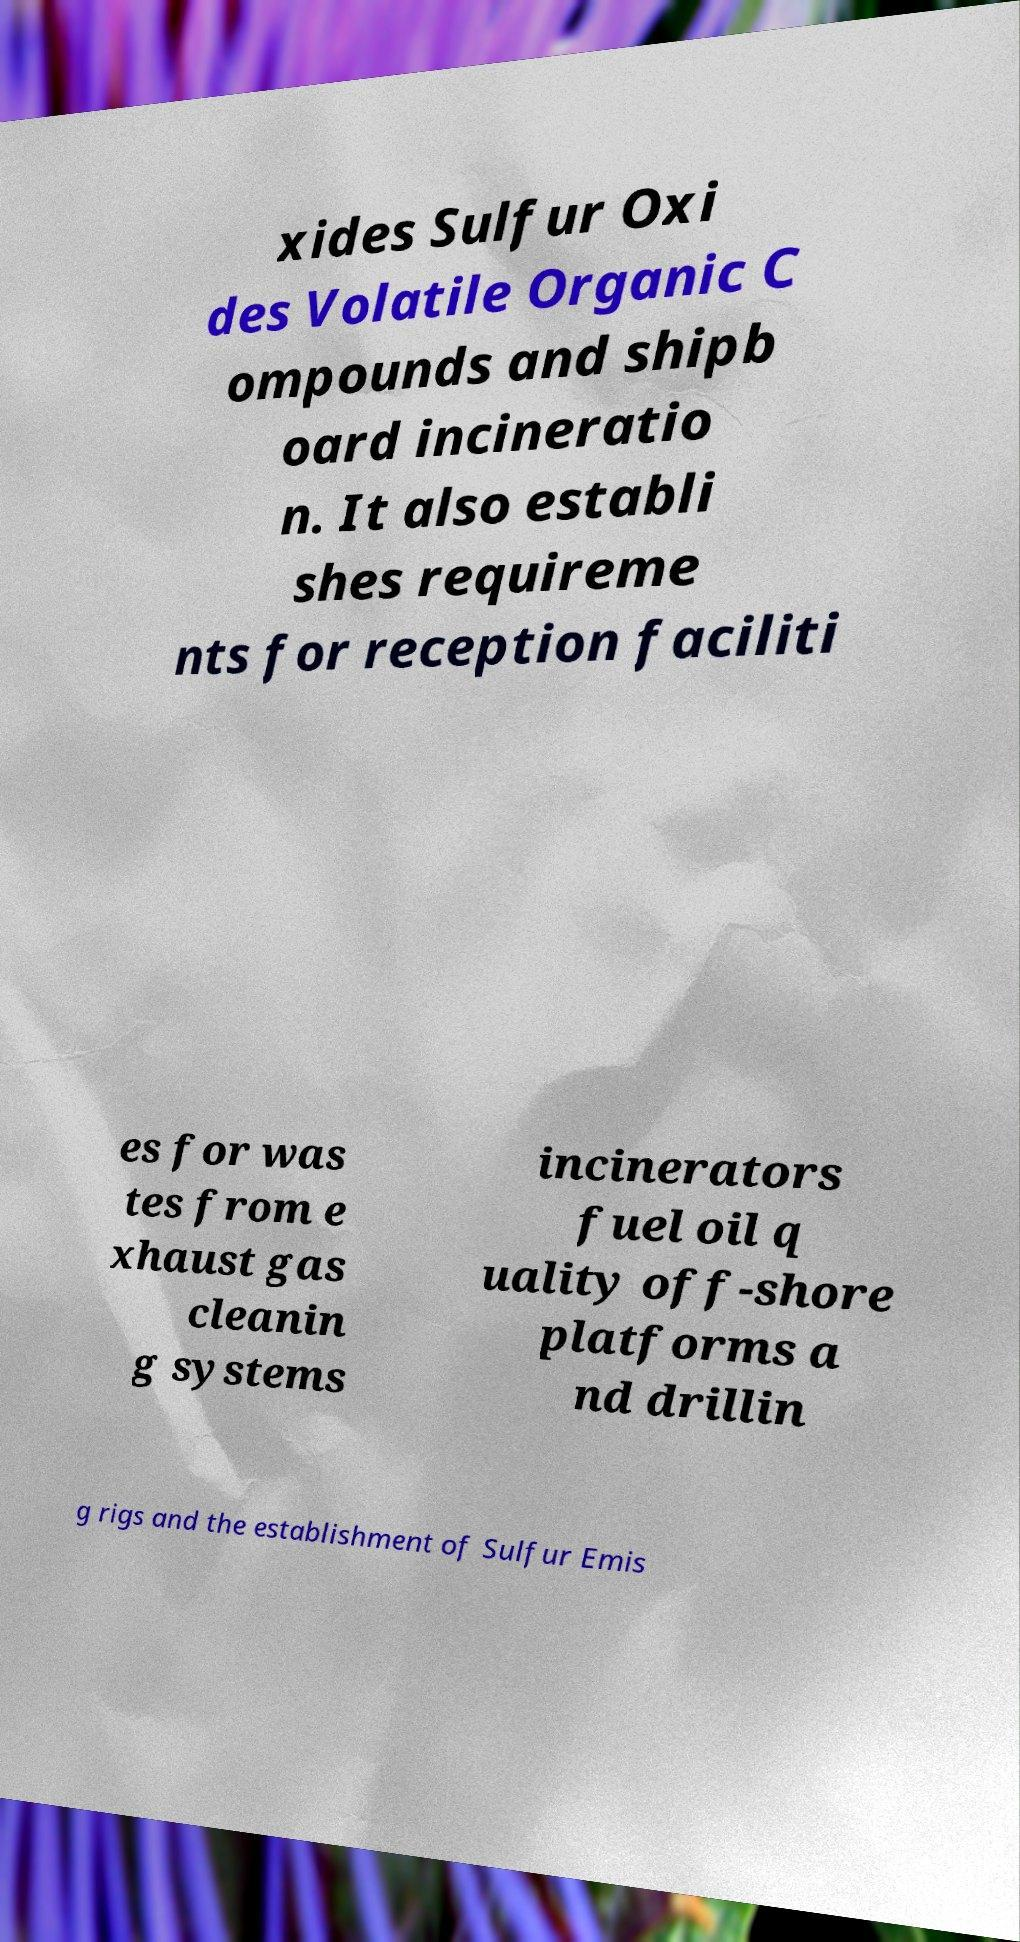There's text embedded in this image that I need extracted. Can you transcribe it verbatim? xides Sulfur Oxi des Volatile Organic C ompounds and shipb oard incineratio n. It also establi shes requireme nts for reception faciliti es for was tes from e xhaust gas cleanin g systems incinerators fuel oil q uality off-shore platforms a nd drillin g rigs and the establishment of Sulfur Emis 